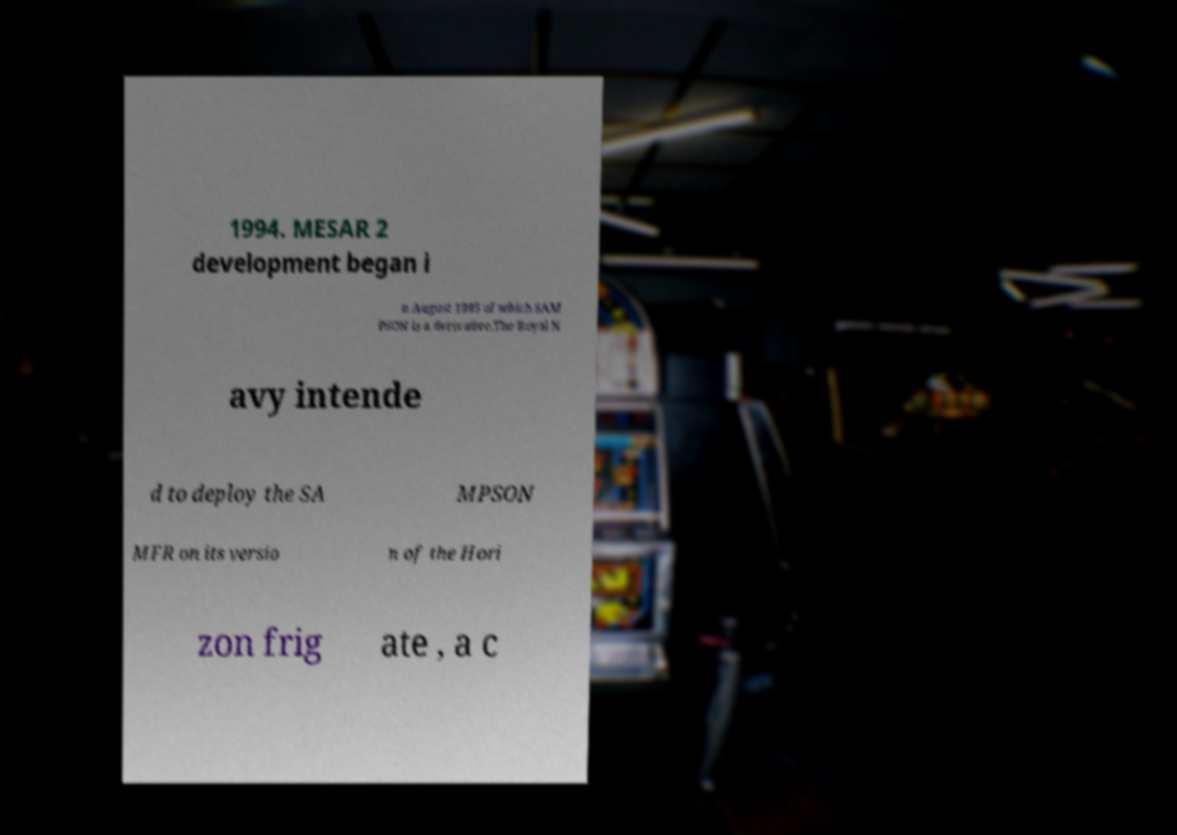What messages or text are displayed in this image? I need them in a readable, typed format. 1994. MESAR 2 development began i n August 1995 of which SAM PSON is a derivative.The Royal N avy intende d to deploy the SA MPSON MFR on its versio n of the Hori zon frig ate , a c 